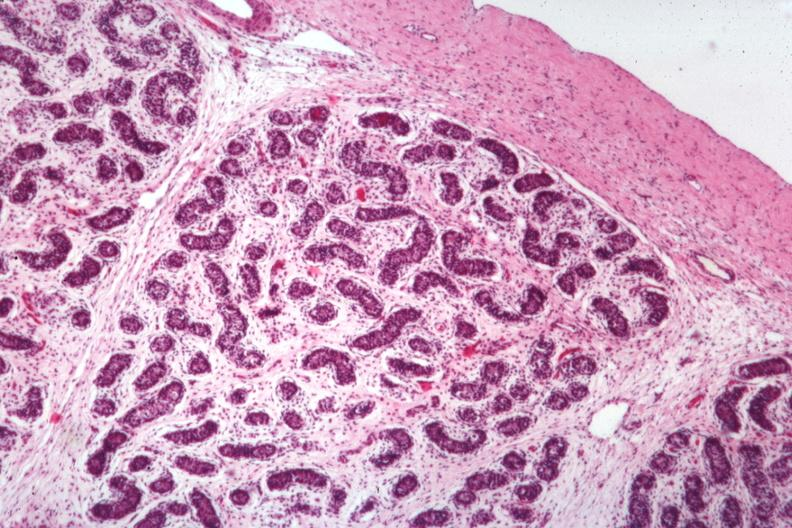what is present?
Answer the question using a single word or phrase. Testicle 